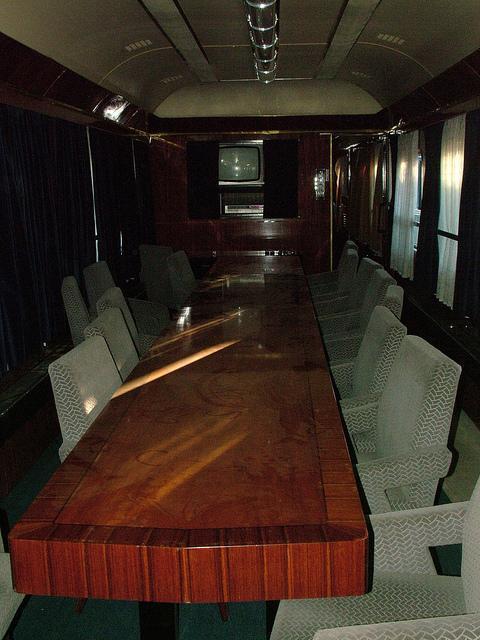The room here might be found where?
Select the accurate answer and provide explanation: 'Answer: answer
Rationale: rationale.'
Options: Luxury hotel, prison, car, train. Answer: train.
Rationale: This long room could be found on a train. 